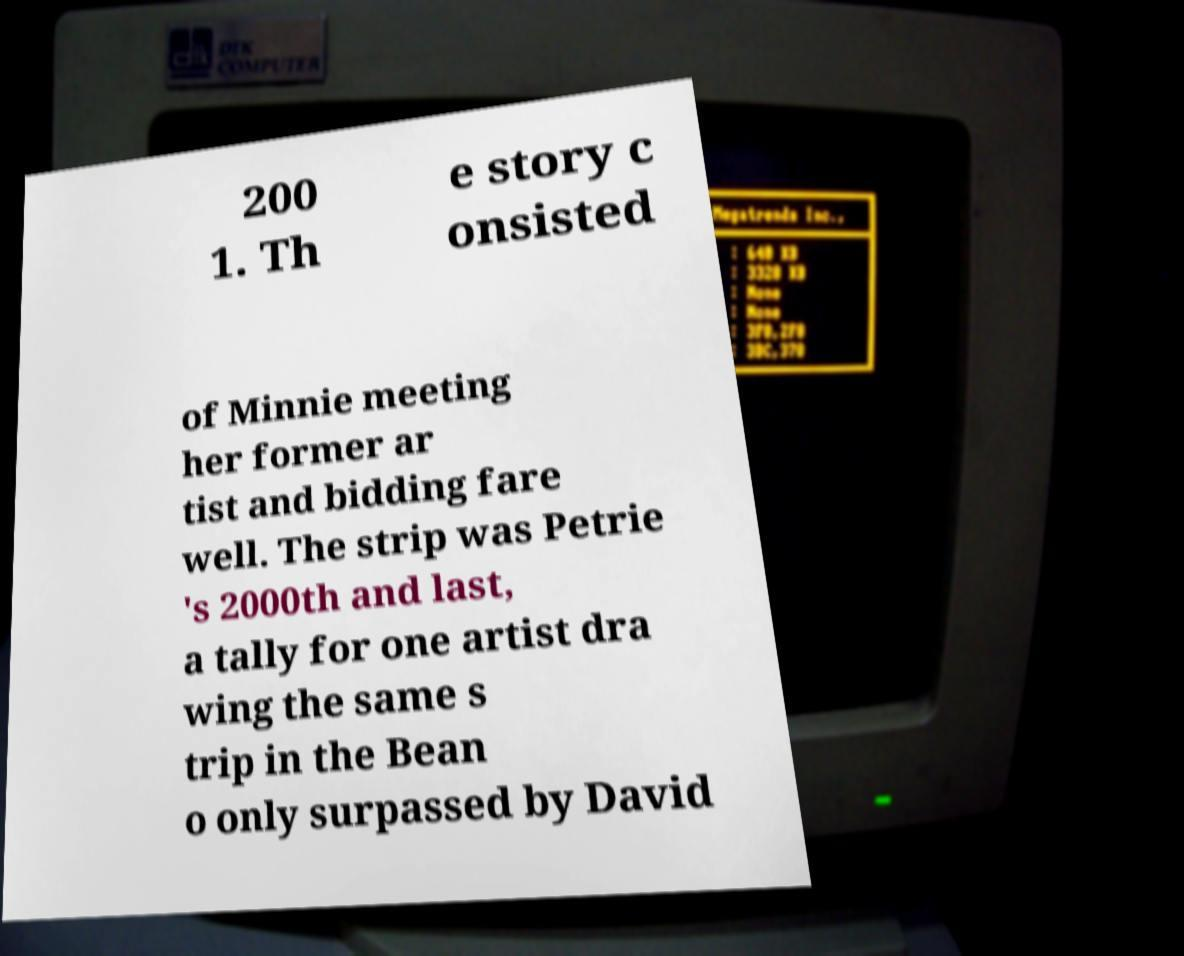Could you extract and type out the text from this image? 200 1. Th e story c onsisted of Minnie meeting her former ar tist and bidding fare well. The strip was Petrie 's 2000th and last, a tally for one artist dra wing the same s trip in the Bean o only surpassed by David 